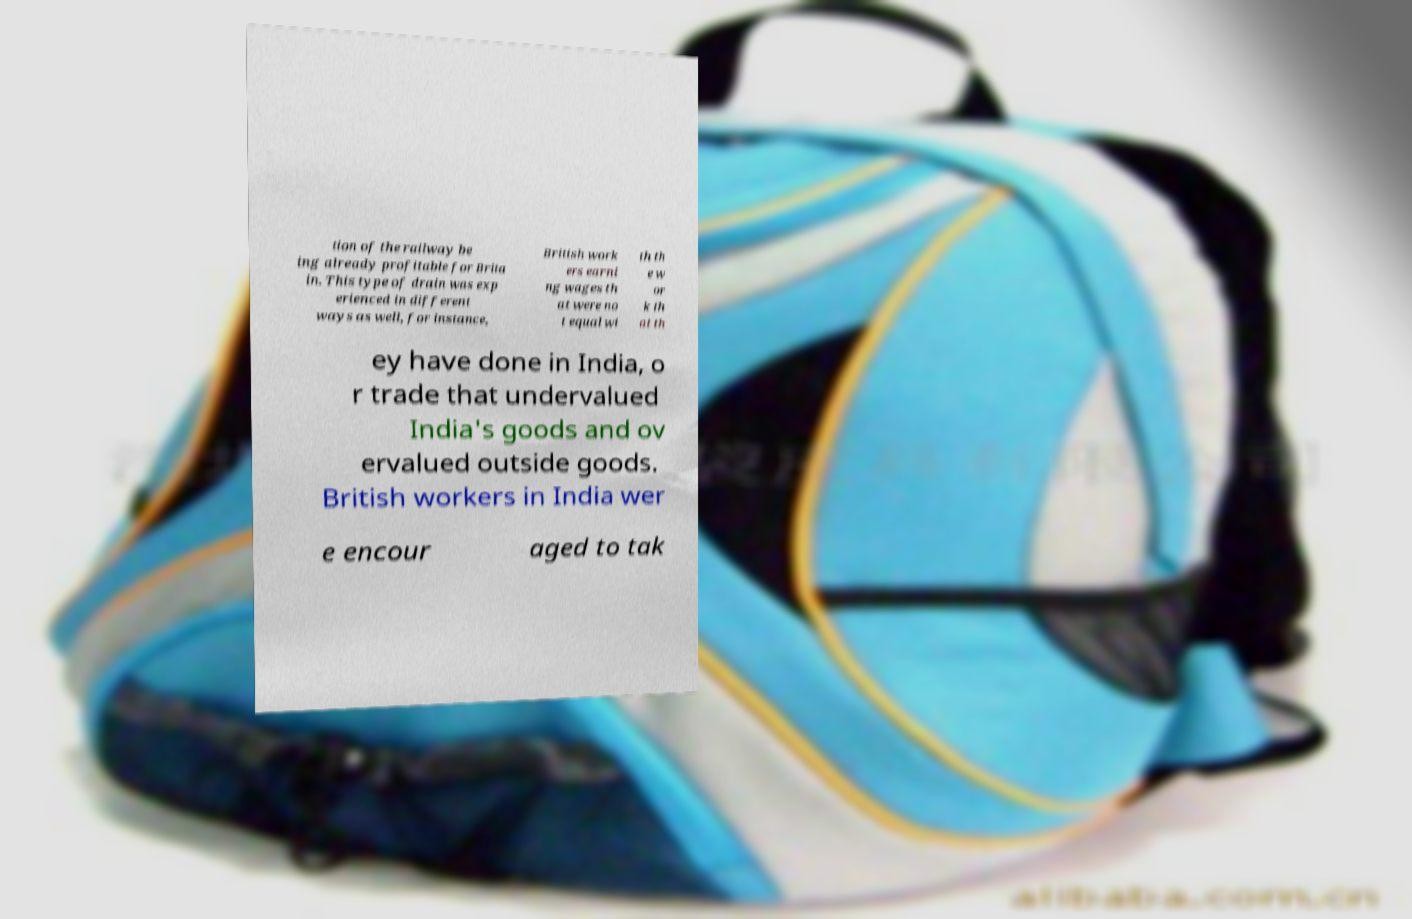Please identify and transcribe the text found in this image. tion of the railway be ing already profitable for Brita in. This type of drain was exp erienced in different ways as well, for instance, British work ers earni ng wages th at were no t equal wi th th e w or k th at th ey have done in India, o r trade that undervalued India's goods and ov ervalued outside goods. British workers in India wer e encour aged to tak 